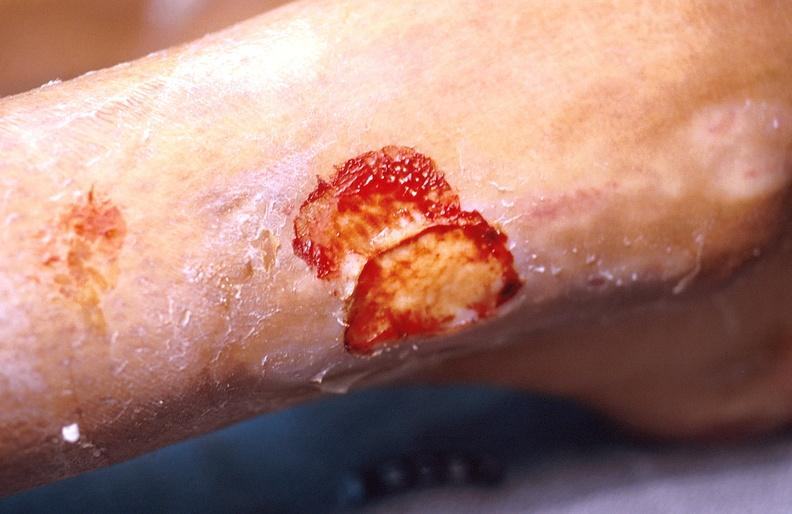what does this image show?
Answer the question using a single word or phrase. Cellulitis 